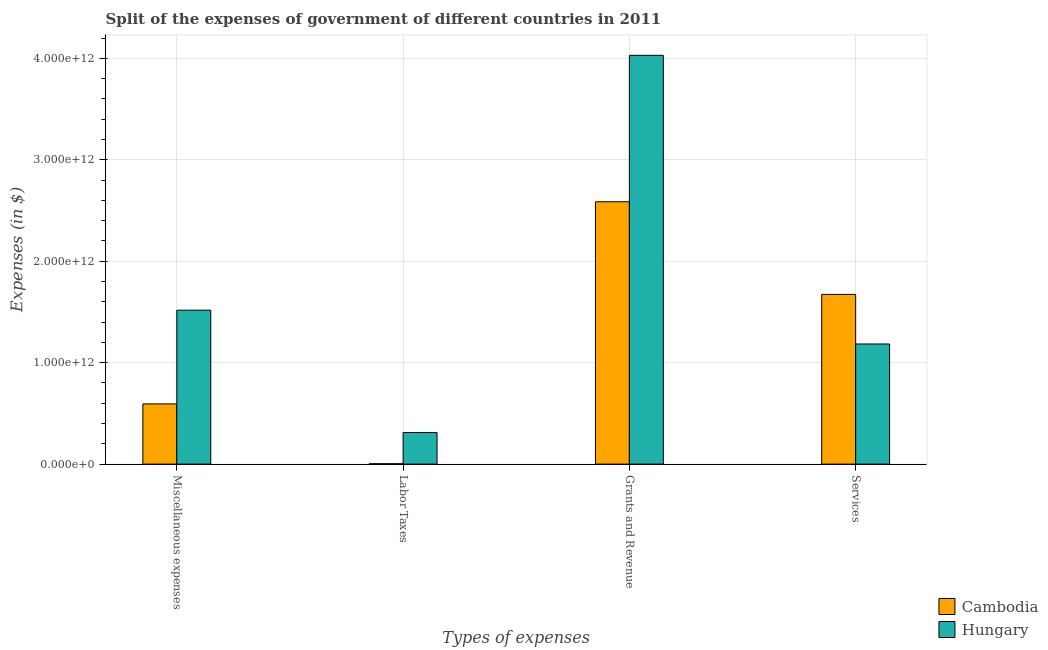How many groups of bars are there?
Provide a succinct answer. 4. Are the number of bars on each tick of the X-axis equal?
Keep it short and to the point. Yes. How many bars are there on the 1st tick from the right?
Make the answer very short. 2. What is the label of the 4th group of bars from the left?
Offer a terse response. Services. What is the amount spent on services in Cambodia?
Give a very brief answer. 1.67e+12. Across all countries, what is the maximum amount spent on services?
Keep it short and to the point. 1.67e+12. Across all countries, what is the minimum amount spent on labor taxes?
Your response must be concise. 3.76e+09. In which country was the amount spent on labor taxes maximum?
Offer a very short reply. Hungary. In which country was the amount spent on services minimum?
Keep it short and to the point. Hungary. What is the total amount spent on miscellaneous expenses in the graph?
Keep it short and to the point. 2.11e+12. What is the difference between the amount spent on miscellaneous expenses in Cambodia and that in Hungary?
Offer a terse response. -9.24e+11. What is the difference between the amount spent on miscellaneous expenses in Hungary and the amount spent on grants and revenue in Cambodia?
Provide a succinct answer. -1.07e+12. What is the average amount spent on services per country?
Give a very brief answer. 1.43e+12. What is the difference between the amount spent on services and amount spent on miscellaneous expenses in Hungary?
Offer a very short reply. -3.33e+11. In how many countries, is the amount spent on grants and revenue greater than 3800000000000 $?
Your response must be concise. 1. What is the ratio of the amount spent on labor taxes in Hungary to that in Cambodia?
Ensure brevity in your answer.  82.73. What is the difference between the highest and the second highest amount spent on services?
Give a very brief answer. 4.89e+11. What is the difference between the highest and the lowest amount spent on services?
Ensure brevity in your answer.  4.89e+11. What does the 2nd bar from the left in Labor Taxes represents?
Provide a short and direct response. Hungary. What does the 1st bar from the right in Miscellaneous expenses represents?
Provide a short and direct response. Hungary. Is it the case that in every country, the sum of the amount spent on miscellaneous expenses and amount spent on labor taxes is greater than the amount spent on grants and revenue?
Offer a very short reply. No. How many countries are there in the graph?
Your answer should be compact. 2. What is the difference between two consecutive major ticks on the Y-axis?
Your response must be concise. 1.00e+12. Does the graph contain any zero values?
Provide a short and direct response. No. Where does the legend appear in the graph?
Provide a short and direct response. Bottom right. How many legend labels are there?
Offer a very short reply. 2. What is the title of the graph?
Your answer should be very brief. Split of the expenses of government of different countries in 2011. What is the label or title of the X-axis?
Your answer should be very brief. Types of expenses. What is the label or title of the Y-axis?
Offer a very short reply. Expenses (in $). What is the Expenses (in $) in Cambodia in Miscellaneous expenses?
Ensure brevity in your answer.  5.93e+11. What is the Expenses (in $) in Hungary in Miscellaneous expenses?
Give a very brief answer. 1.52e+12. What is the Expenses (in $) of Cambodia in Labor Taxes?
Make the answer very short. 3.76e+09. What is the Expenses (in $) in Hungary in Labor Taxes?
Keep it short and to the point. 3.11e+11. What is the Expenses (in $) of Cambodia in Grants and Revenue?
Keep it short and to the point. 2.59e+12. What is the Expenses (in $) of Hungary in Grants and Revenue?
Make the answer very short. 4.03e+12. What is the Expenses (in $) in Cambodia in Services?
Provide a succinct answer. 1.67e+12. What is the Expenses (in $) in Hungary in Services?
Keep it short and to the point. 1.18e+12. Across all Types of expenses, what is the maximum Expenses (in $) of Cambodia?
Your answer should be very brief. 2.59e+12. Across all Types of expenses, what is the maximum Expenses (in $) of Hungary?
Ensure brevity in your answer.  4.03e+12. Across all Types of expenses, what is the minimum Expenses (in $) in Cambodia?
Offer a terse response. 3.76e+09. Across all Types of expenses, what is the minimum Expenses (in $) in Hungary?
Offer a very short reply. 3.11e+11. What is the total Expenses (in $) of Cambodia in the graph?
Your response must be concise. 4.86e+12. What is the total Expenses (in $) of Hungary in the graph?
Your answer should be very brief. 7.04e+12. What is the difference between the Expenses (in $) in Cambodia in Miscellaneous expenses and that in Labor Taxes?
Offer a terse response. 5.90e+11. What is the difference between the Expenses (in $) in Hungary in Miscellaneous expenses and that in Labor Taxes?
Provide a succinct answer. 1.21e+12. What is the difference between the Expenses (in $) of Cambodia in Miscellaneous expenses and that in Grants and Revenue?
Give a very brief answer. -1.99e+12. What is the difference between the Expenses (in $) in Hungary in Miscellaneous expenses and that in Grants and Revenue?
Offer a very short reply. -2.51e+12. What is the difference between the Expenses (in $) of Cambodia in Miscellaneous expenses and that in Services?
Your answer should be very brief. -1.08e+12. What is the difference between the Expenses (in $) in Hungary in Miscellaneous expenses and that in Services?
Offer a terse response. 3.33e+11. What is the difference between the Expenses (in $) in Cambodia in Labor Taxes and that in Grants and Revenue?
Ensure brevity in your answer.  -2.58e+12. What is the difference between the Expenses (in $) of Hungary in Labor Taxes and that in Grants and Revenue?
Your answer should be compact. -3.72e+12. What is the difference between the Expenses (in $) of Cambodia in Labor Taxes and that in Services?
Provide a short and direct response. -1.67e+12. What is the difference between the Expenses (in $) of Hungary in Labor Taxes and that in Services?
Offer a terse response. -8.73e+11. What is the difference between the Expenses (in $) of Cambodia in Grants and Revenue and that in Services?
Offer a terse response. 9.13e+11. What is the difference between the Expenses (in $) in Hungary in Grants and Revenue and that in Services?
Ensure brevity in your answer.  2.85e+12. What is the difference between the Expenses (in $) of Cambodia in Miscellaneous expenses and the Expenses (in $) of Hungary in Labor Taxes?
Give a very brief answer. 2.82e+11. What is the difference between the Expenses (in $) of Cambodia in Miscellaneous expenses and the Expenses (in $) of Hungary in Grants and Revenue?
Your response must be concise. -3.44e+12. What is the difference between the Expenses (in $) in Cambodia in Miscellaneous expenses and the Expenses (in $) in Hungary in Services?
Keep it short and to the point. -5.91e+11. What is the difference between the Expenses (in $) in Cambodia in Labor Taxes and the Expenses (in $) in Hungary in Grants and Revenue?
Give a very brief answer. -4.03e+12. What is the difference between the Expenses (in $) of Cambodia in Labor Taxes and the Expenses (in $) of Hungary in Services?
Your response must be concise. -1.18e+12. What is the difference between the Expenses (in $) of Cambodia in Grants and Revenue and the Expenses (in $) of Hungary in Services?
Ensure brevity in your answer.  1.40e+12. What is the average Expenses (in $) in Cambodia per Types of expenses?
Ensure brevity in your answer.  1.21e+12. What is the average Expenses (in $) of Hungary per Types of expenses?
Give a very brief answer. 1.76e+12. What is the difference between the Expenses (in $) in Cambodia and Expenses (in $) in Hungary in Miscellaneous expenses?
Ensure brevity in your answer.  -9.24e+11. What is the difference between the Expenses (in $) of Cambodia and Expenses (in $) of Hungary in Labor Taxes?
Your response must be concise. -3.08e+11. What is the difference between the Expenses (in $) in Cambodia and Expenses (in $) in Hungary in Grants and Revenue?
Offer a terse response. -1.44e+12. What is the difference between the Expenses (in $) in Cambodia and Expenses (in $) in Hungary in Services?
Give a very brief answer. 4.89e+11. What is the ratio of the Expenses (in $) of Cambodia in Miscellaneous expenses to that in Labor Taxes?
Your answer should be compact. 157.69. What is the ratio of the Expenses (in $) of Hungary in Miscellaneous expenses to that in Labor Taxes?
Your response must be concise. 4.87. What is the ratio of the Expenses (in $) in Cambodia in Miscellaneous expenses to that in Grants and Revenue?
Offer a very short reply. 0.23. What is the ratio of the Expenses (in $) in Hungary in Miscellaneous expenses to that in Grants and Revenue?
Your response must be concise. 0.38. What is the ratio of the Expenses (in $) in Cambodia in Miscellaneous expenses to that in Services?
Your answer should be compact. 0.35. What is the ratio of the Expenses (in $) of Hungary in Miscellaneous expenses to that in Services?
Ensure brevity in your answer.  1.28. What is the ratio of the Expenses (in $) of Cambodia in Labor Taxes to that in Grants and Revenue?
Give a very brief answer. 0. What is the ratio of the Expenses (in $) of Hungary in Labor Taxes to that in Grants and Revenue?
Offer a terse response. 0.08. What is the ratio of the Expenses (in $) in Cambodia in Labor Taxes to that in Services?
Offer a terse response. 0. What is the ratio of the Expenses (in $) in Hungary in Labor Taxes to that in Services?
Your answer should be compact. 0.26. What is the ratio of the Expenses (in $) of Cambodia in Grants and Revenue to that in Services?
Ensure brevity in your answer.  1.55. What is the ratio of the Expenses (in $) in Hungary in Grants and Revenue to that in Services?
Your answer should be very brief. 3.4. What is the difference between the highest and the second highest Expenses (in $) of Cambodia?
Your answer should be compact. 9.13e+11. What is the difference between the highest and the second highest Expenses (in $) in Hungary?
Provide a short and direct response. 2.51e+12. What is the difference between the highest and the lowest Expenses (in $) of Cambodia?
Your answer should be very brief. 2.58e+12. What is the difference between the highest and the lowest Expenses (in $) in Hungary?
Keep it short and to the point. 3.72e+12. 